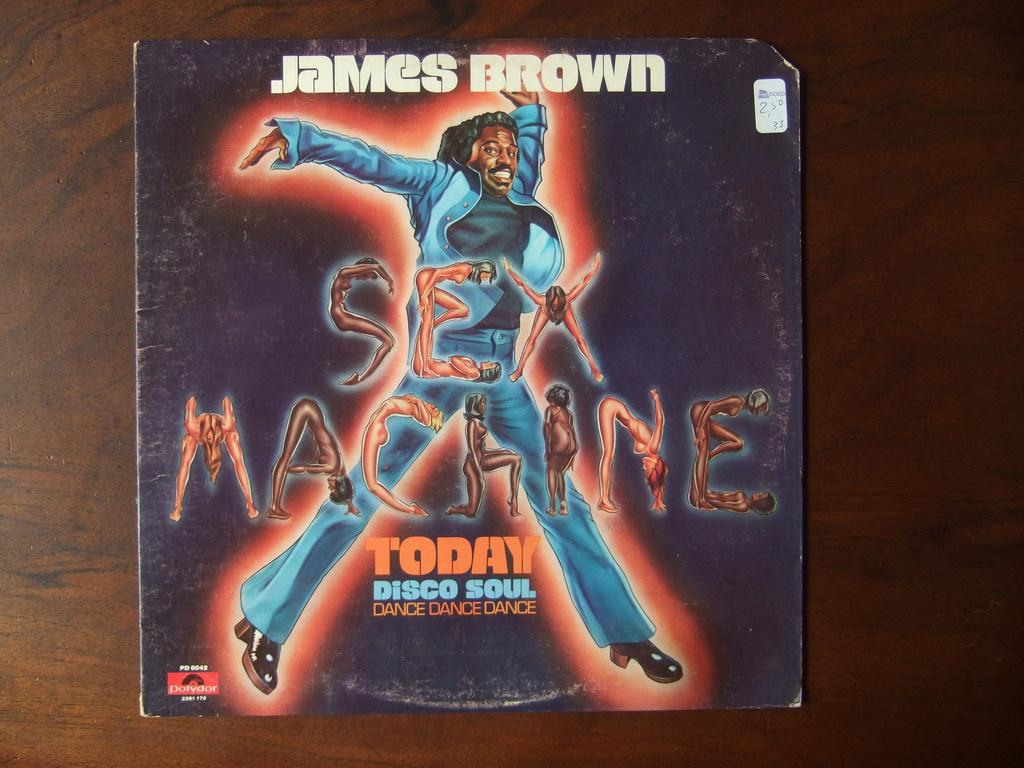<image>
Describe the image concisely. Album cover for James Brown's long awaited "Sex Machine". 